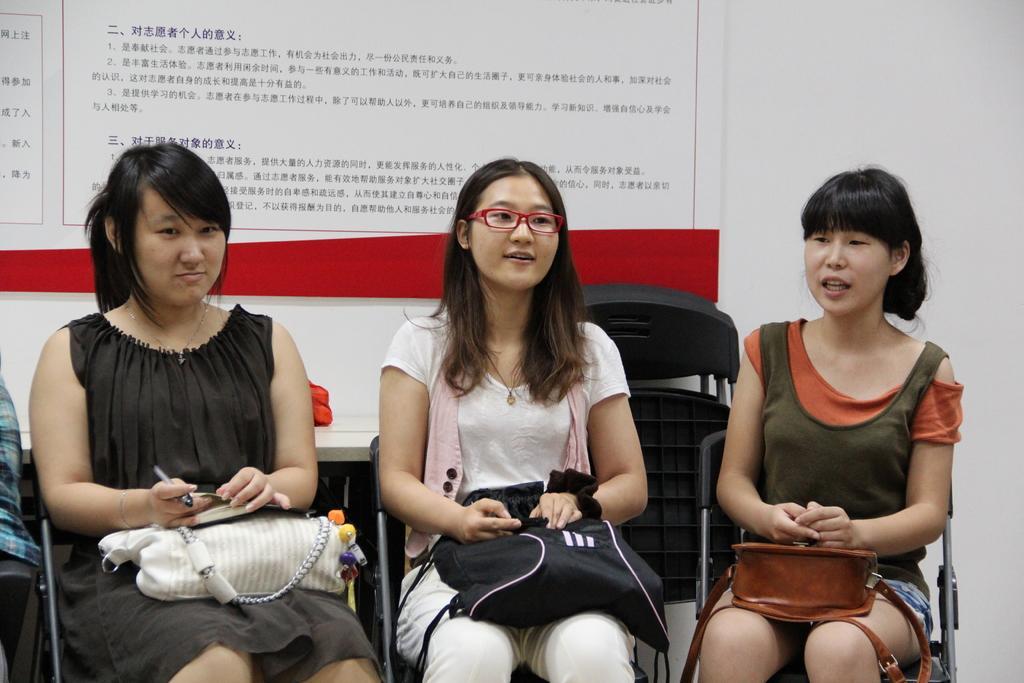How would you summarize this image in a sentence or two? In this image a three woman are sitting on the chairs ,they three are staring at some thing. In the back ground there is a table and a poster with some written text. On the right a woman is there ,her hair is short and i think she is speaking something. 